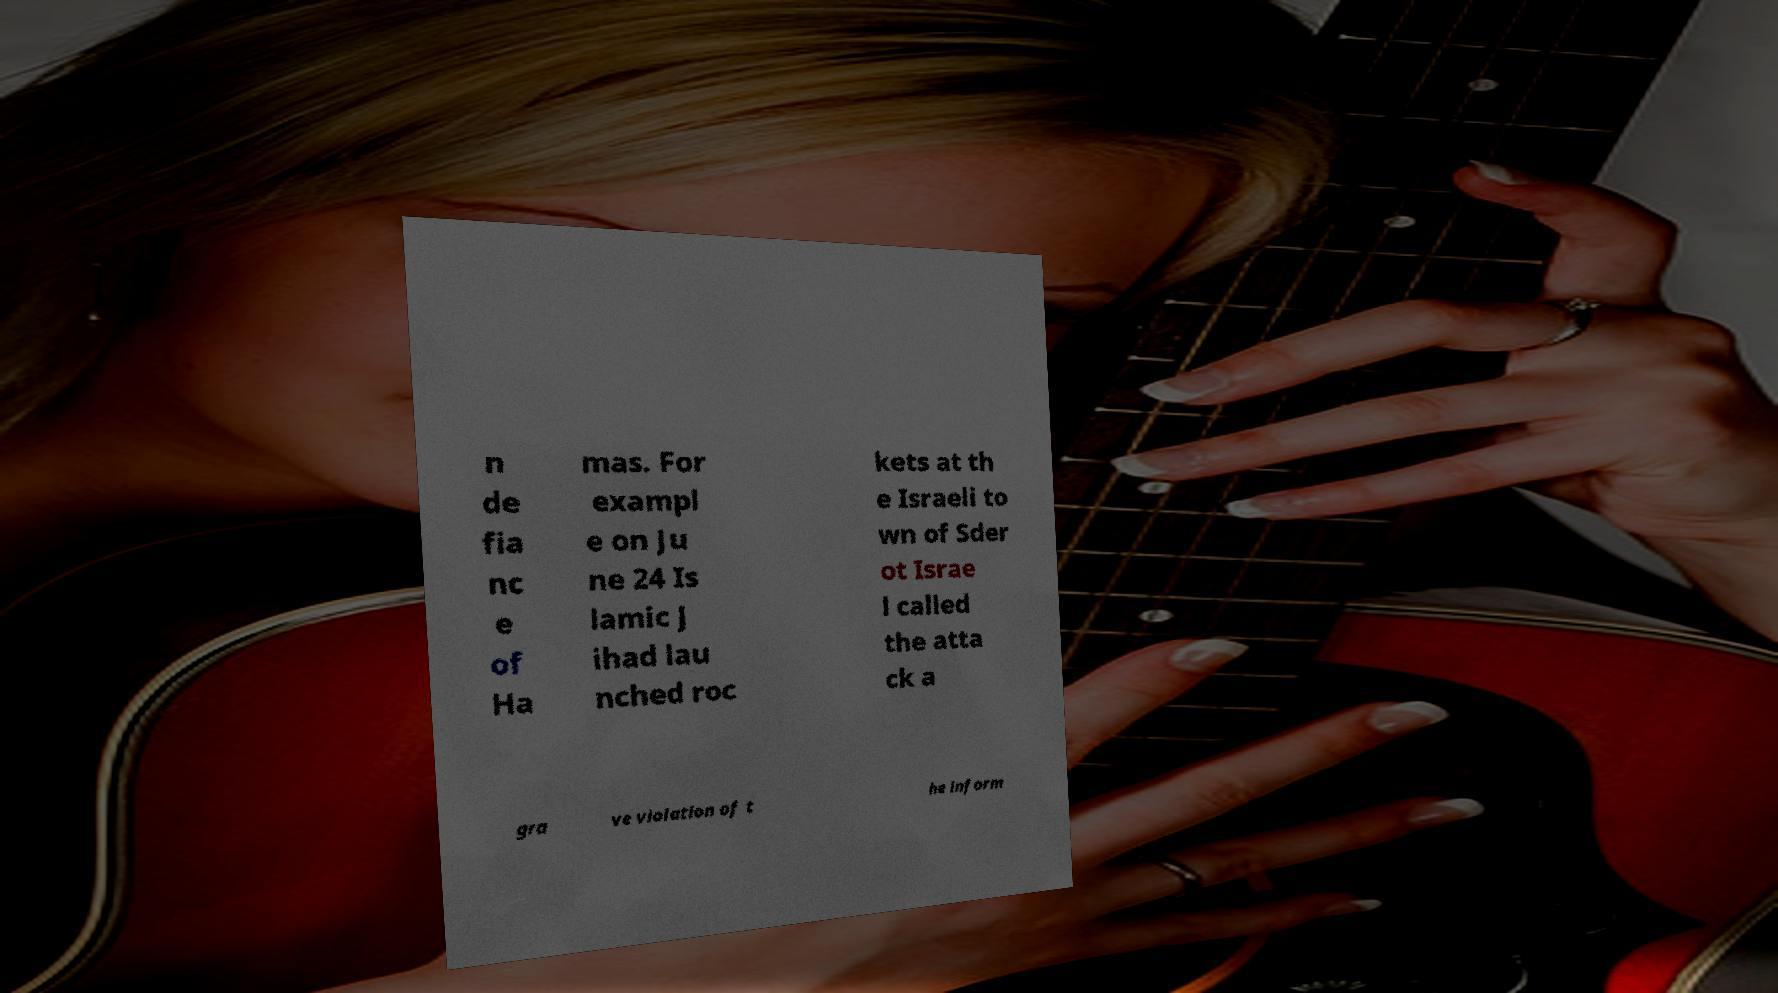Please identify and transcribe the text found in this image. n de fia nc e of Ha mas. For exampl e on Ju ne 24 Is lamic J ihad lau nched roc kets at th e Israeli to wn of Sder ot Israe l called the atta ck a gra ve violation of t he inform 